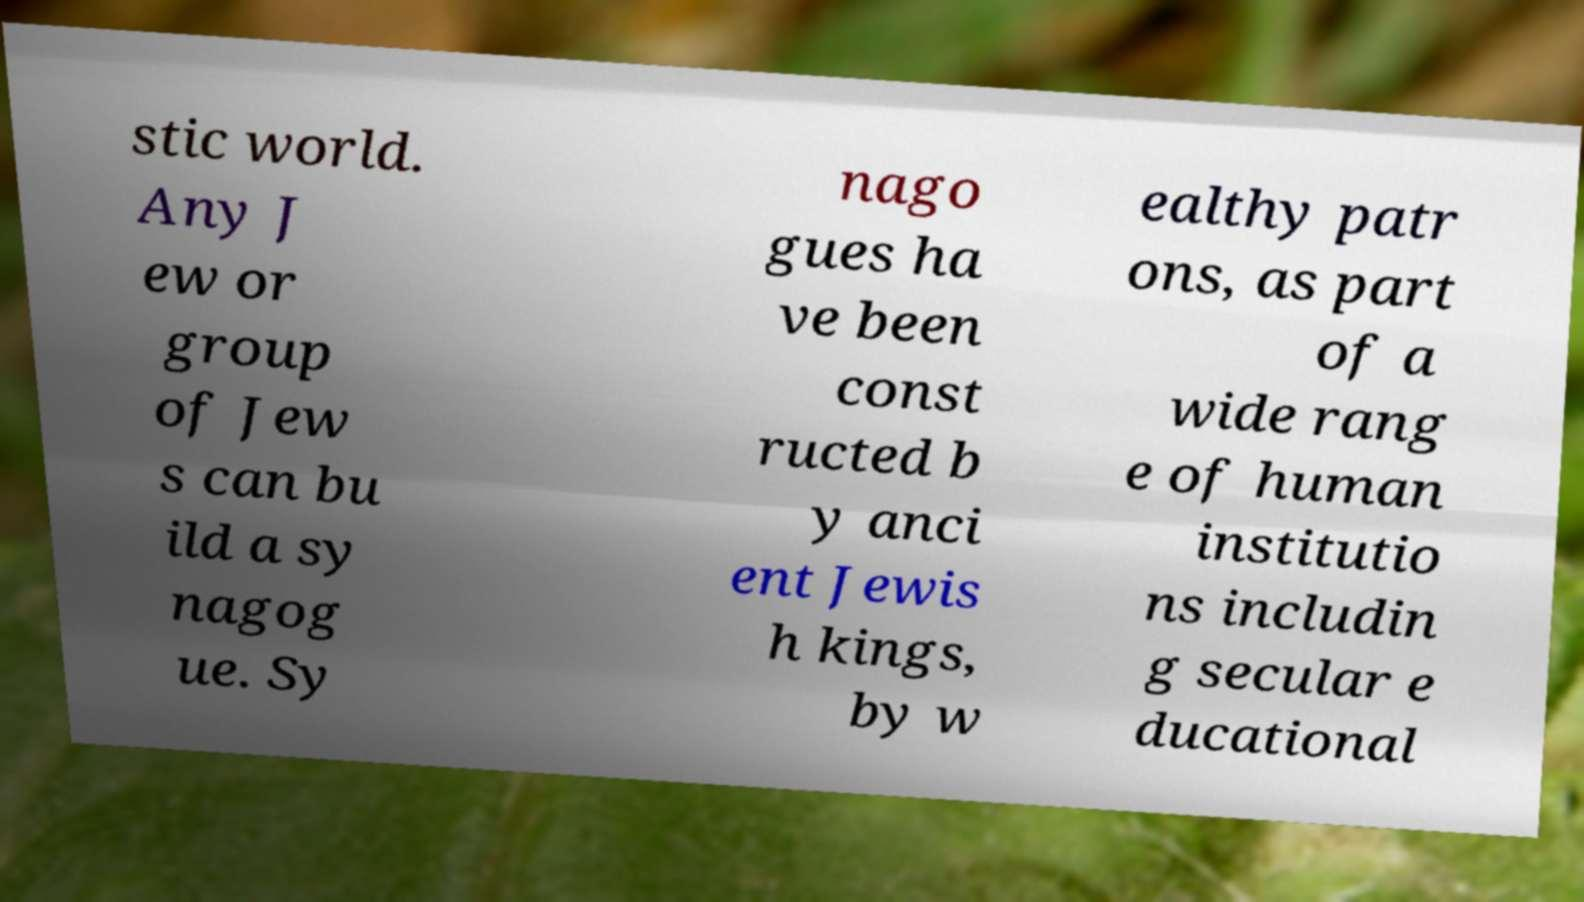There's text embedded in this image that I need extracted. Can you transcribe it verbatim? stic world. Any J ew or group of Jew s can bu ild a sy nagog ue. Sy nago gues ha ve been const ructed b y anci ent Jewis h kings, by w ealthy patr ons, as part of a wide rang e of human institutio ns includin g secular e ducational 